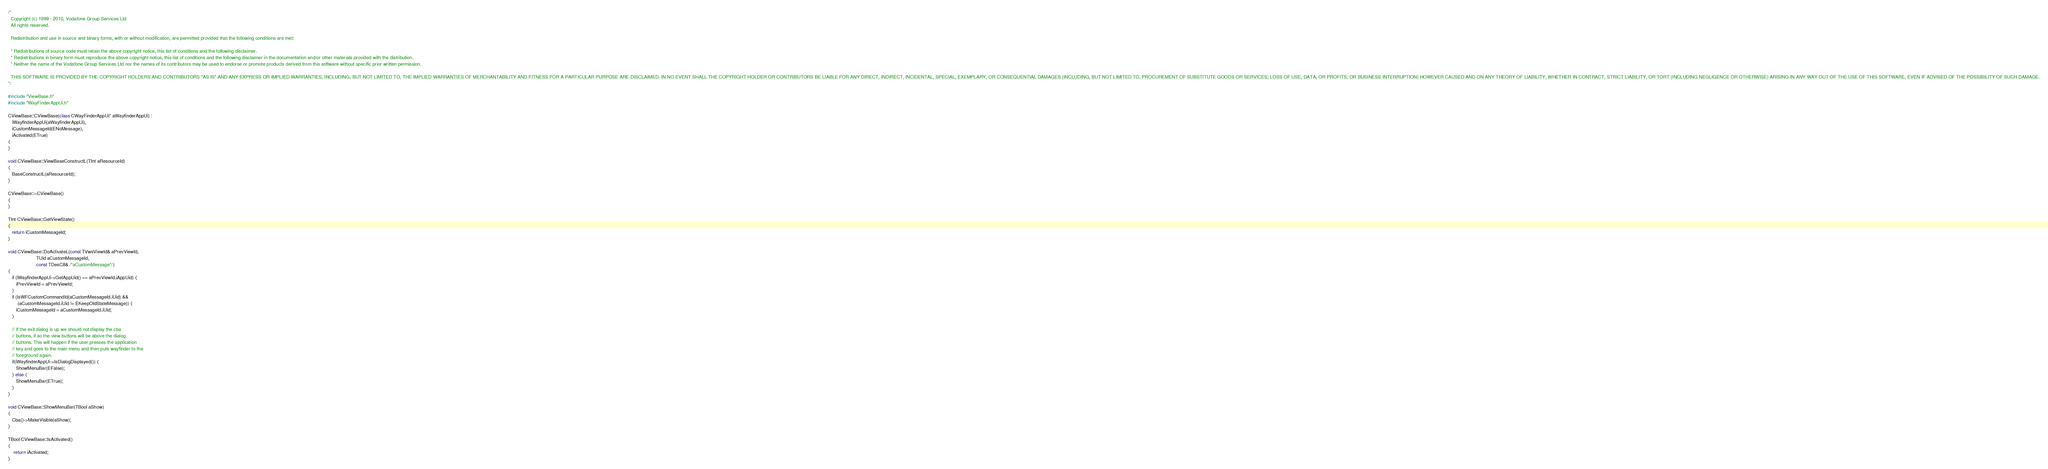Convert code to text. <code><loc_0><loc_0><loc_500><loc_500><_C++_>/*
  Copyright (c) 1999 - 2010, Vodafone Group Services Ltd
  All rights reserved.

  Redistribution and use in source and binary forms, with or without modification, are permitted provided that the following conditions are met:

  * Redistributions of source code must retain the above copyright notice, this list of conditions and the following disclaimer.
  * Redistributions in binary form must reproduce the above copyright notice, this list of conditions and the following disclaimer in the documentation and/or other materials provided with the distribution.
  * Neither the name of the Vodafone Group Services Ltd nor the names of its contributors may be used to endorse or promote products derived from this software without specific prior written permission.

  THIS SOFTWARE IS PROVIDED BY THE COPYRIGHT HOLDERS AND CONTRIBUTORS "AS IS" AND ANY EXPRESS OR IMPLIED WARRANTIES, INCLUDING, BUT NOT LIMITED TO, THE IMPLIED WARRANTIES OF MERCHANTABILITY AND FITNESS FOR A PARTICULAR PURPOSE ARE DISCLAIMED. IN NO EVENT SHALL THE COPYRIGHT HOLDER OR CONTRIBUTORS BE LIABLE FOR ANY DIRECT, INDIRECT, INCIDENTAL, SPECIAL, EXEMPLARY, OR CONSEQUENTIAL DAMAGES (INCLUDING, BUT NOT LIMITED TO, PROCUREMENT OF SUBSTITUTE GOODS OR SERVICES; LOSS OF USE, DATA, OR PROFITS; OR BUSINESS INTERRUPTION) HOWEVER CAUSED AND ON ANY THEORY OF LIABILITY, WHETHER IN CONTRACT, STRICT LIABILITY, OR TORT (INCLUDING NEGLIGENCE OR OTHERWISE) ARISING IN ANY WAY OUT OF THE USE OF THIS SOFTWARE, EVEN IF ADVISED OF THE POSSIBILITY OF SUCH DAMAGE.
*/

#include "ViewBase.h"
#include "WayFinderAppUi.h"

CViewBase::CViewBase(class CWayFinderAppUi* aWayfinderAppUi) :
   iWayfinderAppUi(aWayfinderAppUi),
   iCustomMessageId(ENoMessage),
   iActivated(ETrue)
{
}

void CViewBase::ViewBaseConstructL(TInt aResourceId)
{
   BaseConstructL(aResourceId);
}

CViewBase::~CViewBase()
{
}

TInt CViewBase::GetViewState()
{
   return iCustomMessageId;
}

void CViewBase::DoActivateL(const TVwsViewId& aPrevViewId,
                     TUid aCustomMessageId,
                     const TDesC8& /*aCustomMessage*/)
{
   if (iWayfinderAppUi->GetAppUid() == aPrevViewId.iAppUid) {
      iPrevViewId = aPrevViewId;
   } 
   if (IsWFCustomCommandId(aCustomMessageId.iUid) &&
       (aCustomMessageId.iUid != EKeepOldStateMessage)) {
      iCustomMessageId = aCustomMessageId.iUid;
   } 

   // If the exit dialog is up we should not display the cba
   // buttons, if so the view buttons will be above the dialog
   // buttons. This will happen if the user presses the application
   // key and goes to the main menu and then puts wayfinder to the 
   // foreground again.
   if(iWayfinderAppUi->IsDialogDisplayed()) {
      ShowMenuBar(EFalse);
   } else {
      ShowMenuBar(ETrue);
   }
}

void CViewBase::ShowMenuBar(TBool aShow)
{
   Cba()->MakeVisible(aShow);   
}

TBool CViewBase::IsActivated() 
{
	return iActivated;
}
</code> 